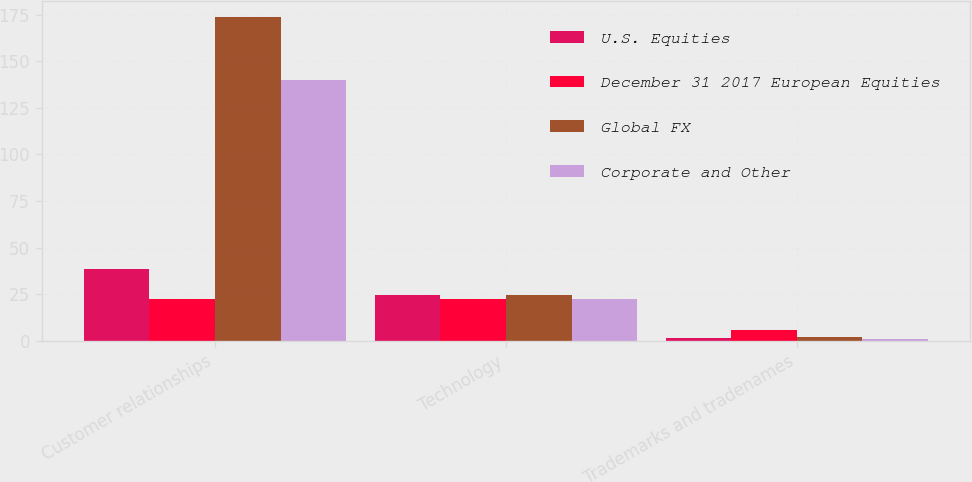Convert chart to OTSL. <chart><loc_0><loc_0><loc_500><loc_500><stacked_bar_chart><ecel><fcel>Customer relationships<fcel>Technology<fcel>Trademarks and tradenames<nl><fcel>U.S. Equities<fcel>38.8<fcel>24.6<fcel>1.7<nl><fcel>December 31 2017 European Equities<fcel>22.5<fcel>22.5<fcel>6<nl><fcel>Global FX<fcel>173.7<fcel>24.4<fcel>2<nl><fcel>Corporate and Other<fcel>140<fcel>22.5<fcel>1.2<nl></chart> 